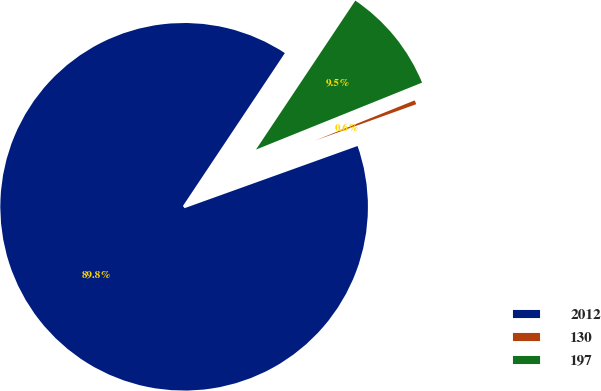<chart> <loc_0><loc_0><loc_500><loc_500><pie_chart><fcel>2012<fcel>130<fcel>197<nl><fcel>89.85%<fcel>0.61%<fcel>9.54%<nl></chart> 